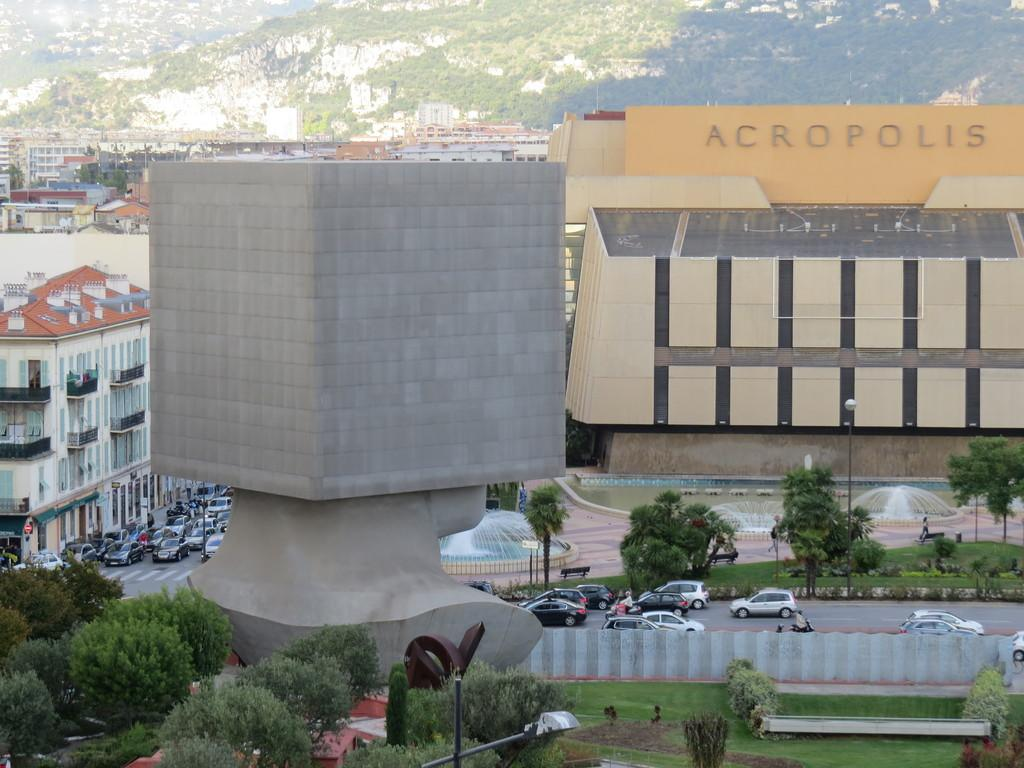What type of structures can be seen in the image? There are buildings in the image. What mode of transportation can be seen in the image? Motor vehicles are present in the image. What type of water feature is visible in the image? Fountains are visible in the image. What type of natural feature is present in the image? Hills are in the image. What type of pathway is present in the image? There is a road in the image. What type of surface is visible in the image? The ground is visible in the image. What type of vegetation is present in the image? Bushes and trees are visible in the image. What type of seating is present on the ground in the image? Benches are on the ground in the image. Where are the toys located in the image? There are no toys present in the image. What type of downtown area is visible in the image? The image does not depict a downtown area; it shows a combination of natural and man-made features. 